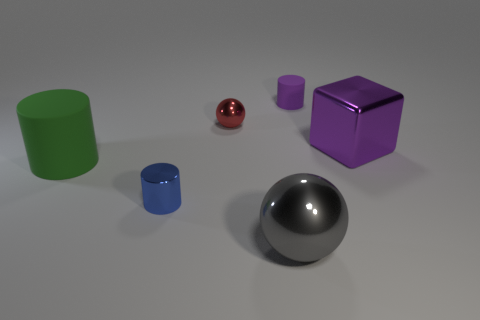What size is the cylinder that is the same color as the large cube?
Your answer should be compact. Small. Is the size of the rubber cylinder that is on the left side of the big gray metallic thing the same as the metal ball that is to the left of the gray metallic thing?
Offer a terse response. No. What number of things are blue cylinders or small red things?
Your response must be concise. 2. What shape is the purple rubber object?
Your answer should be very brief. Cylinder. What size is the gray shiny object that is the same shape as the red object?
Your answer should be very brief. Large. Is there anything else that is made of the same material as the cube?
Your answer should be compact. Yes. What size is the cylinder that is on the left side of the small metallic thing in front of the big block?
Your response must be concise. Large. Are there the same number of purple blocks that are left of the blue shiny object and tiny blue objects?
Offer a terse response. No. What number of other things are the same color as the metallic cube?
Your answer should be very brief. 1. Are there fewer rubber cylinders in front of the green rubber thing than cubes?
Ensure brevity in your answer.  Yes. 